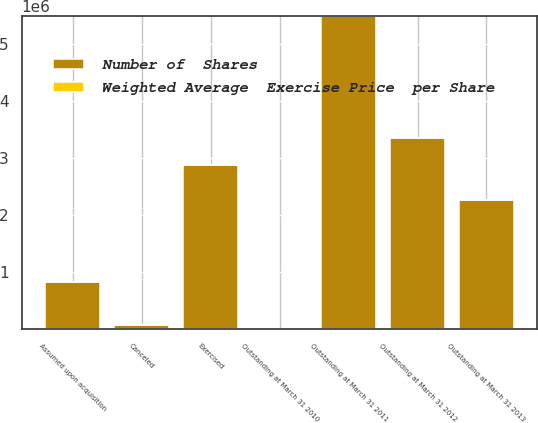<chart> <loc_0><loc_0><loc_500><loc_500><stacked_bar_chart><ecel><fcel>Outstanding at March 31 2010<fcel>Exercised<fcel>Canceled<fcel>Outstanding at March 31 2011<fcel>Outstanding at March 31 2012<fcel>Assumed upon acquisition<fcel>Outstanding at March 31 2013<nl><fcel>Number of  Shares<fcel>29.39<fcel>2.88536e+06<fcel>77490<fcel>5.49692e+06<fcel>3.361e+06<fcel>827707<fcel>2.2698e+06<nl><fcel>Weighted Average  Exercise Price  per Share<fcel>24.52<fcel>23.09<fcel>29.39<fcel>25.21<fcel>25<fcel>19.32<fcel>25.58<nl></chart> 